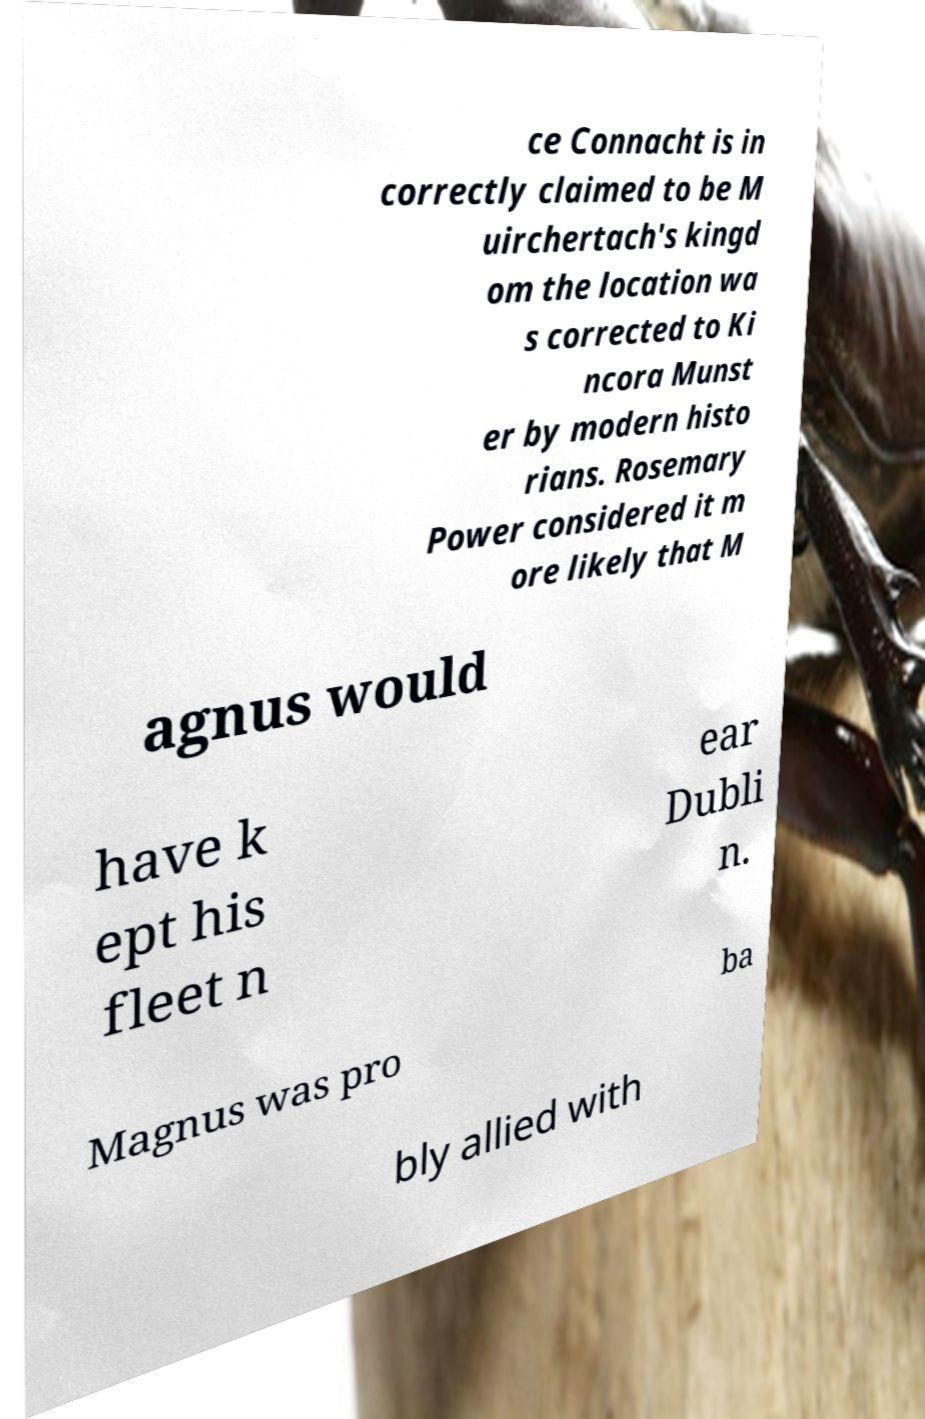I need the written content from this picture converted into text. Can you do that? ce Connacht is in correctly claimed to be M uirchertach's kingd om the location wa s corrected to Ki ncora Munst er by modern histo rians. Rosemary Power considered it m ore likely that M agnus would have k ept his fleet n ear Dubli n. Magnus was pro ba bly allied with 